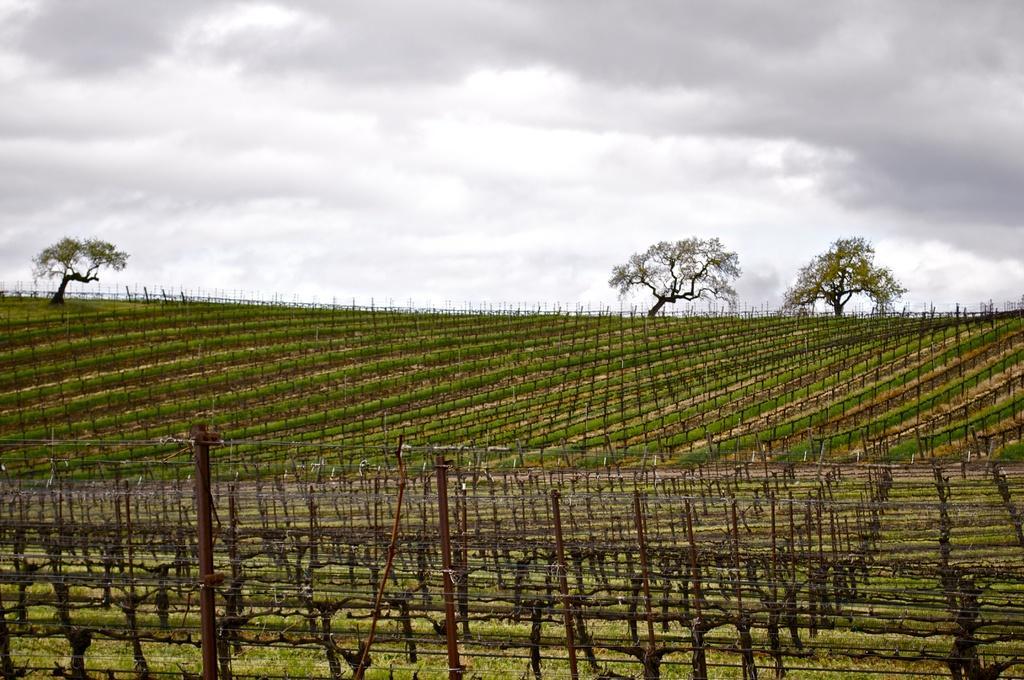Please provide a concise description of this image. In this image we can see trees, grass on the ground and we can also see the sky. 